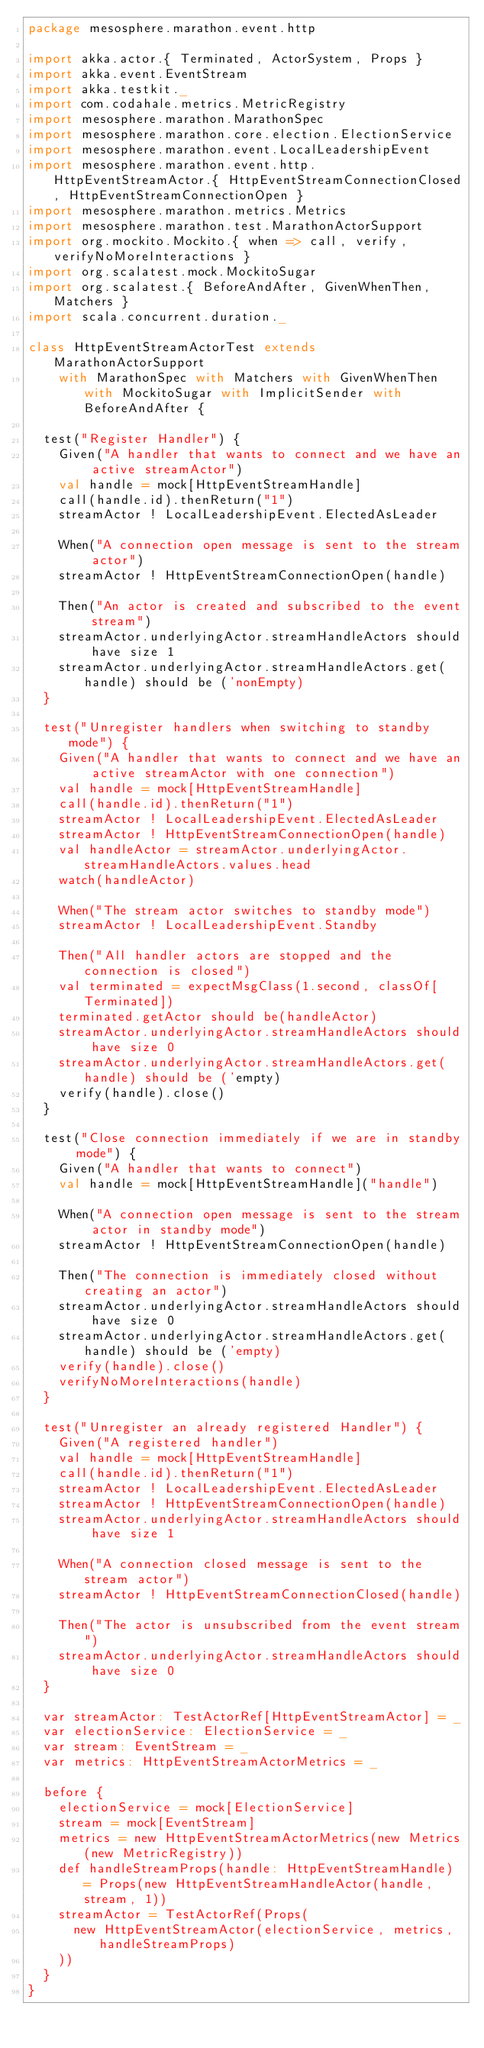<code> <loc_0><loc_0><loc_500><loc_500><_Scala_>package mesosphere.marathon.event.http

import akka.actor.{ Terminated, ActorSystem, Props }
import akka.event.EventStream
import akka.testkit._
import com.codahale.metrics.MetricRegistry
import mesosphere.marathon.MarathonSpec
import mesosphere.marathon.core.election.ElectionService
import mesosphere.marathon.event.LocalLeadershipEvent
import mesosphere.marathon.event.http.HttpEventStreamActor.{ HttpEventStreamConnectionClosed, HttpEventStreamConnectionOpen }
import mesosphere.marathon.metrics.Metrics
import mesosphere.marathon.test.MarathonActorSupport
import org.mockito.Mockito.{ when => call, verify, verifyNoMoreInteractions }
import org.scalatest.mock.MockitoSugar
import org.scalatest.{ BeforeAndAfter, GivenWhenThen, Matchers }
import scala.concurrent.duration._

class HttpEventStreamActorTest extends MarathonActorSupport
    with MarathonSpec with Matchers with GivenWhenThen with MockitoSugar with ImplicitSender with BeforeAndAfter {

  test("Register Handler") {
    Given("A handler that wants to connect and we have an active streamActor")
    val handle = mock[HttpEventStreamHandle]
    call(handle.id).thenReturn("1")
    streamActor ! LocalLeadershipEvent.ElectedAsLeader

    When("A connection open message is sent to the stream actor")
    streamActor ! HttpEventStreamConnectionOpen(handle)

    Then("An actor is created and subscribed to the event stream")
    streamActor.underlyingActor.streamHandleActors should have size 1
    streamActor.underlyingActor.streamHandleActors.get(handle) should be ('nonEmpty)
  }

  test("Unregister handlers when switching to standby mode") {
    Given("A handler that wants to connect and we have an active streamActor with one connection")
    val handle = mock[HttpEventStreamHandle]
    call(handle.id).thenReturn("1")
    streamActor ! LocalLeadershipEvent.ElectedAsLeader
    streamActor ! HttpEventStreamConnectionOpen(handle)
    val handleActor = streamActor.underlyingActor.streamHandleActors.values.head
    watch(handleActor)

    When("The stream actor switches to standby mode")
    streamActor ! LocalLeadershipEvent.Standby

    Then("All handler actors are stopped and the connection is closed")
    val terminated = expectMsgClass(1.second, classOf[Terminated])
    terminated.getActor should be(handleActor)
    streamActor.underlyingActor.streamHandleActors should have size 0
    streamActor.underlyingActor.streamHandleActors.get(handle) should be ('empty)
    verify(handle).close()
  }

  test("Close connection immediately if we are in standby mode") {
    Given("A handler that wants to connect")
    val handle = mock[HttpEventStreamHandle]("handle")

    When("A connection open message is sent to the stream actor in standby mode")
    streamActor ! HttpEventStreamConnectionOpen(handle)

    Then("The connection is immediately closed without creating an actor")
    streamActor.underlyingActor.streamHandleActors should have size 0
    streamActor.underlyingActor.streamHandleActors.get(handle) should be ('empty)
    verify(handle).close()
    verifyNoMoreInteractions(handle)
  }

  test("Unregister an already registered Handler") {
    Given("A registered handler")
    val handle = mock[HttpEventStreamHandle]
    call(handle.id).thenReturn("1")
    streamActor ! LocalLeadershipEvent.ElectedAsLeader
    streamActor ! HttpEventStreamConnectionOpen(handle)
    streamActor.underlyingActor.streamHandleActors should have size 1

    When("A connection closed message is sent to the stream actor")
    streamActor ! HttpEventStreamConnectionClosed(handle)

    Then("The actor is unsubscribed from the event stream")
    streamActor.underlyingActor.streamHandleActors should have size 0
  }

  var streamActor: TestActorRef[HttpEventStreamActor] = _
  var electionService: ElectionService = _
  var stream: EventStream = _
  var metrics: HttpEventStreamActorMetrics = _

  before {
    electionService = mock[ElectionService]
    stream = mock[EventStream]
    metrics = new HttpEventStreamActorMetrics(new Metrics(new MetricRegistry))
    def handleStreamProps(handle: HttpEventStreamHandle) = Props(new HttpEventStreamHandleActor(handle, stream, 1))
    streamActor = TestActorRef(Props(
      new HttpEventStreamActor(electionService, metrics, handleStreamProps)
    ))
  }
}
</code> 